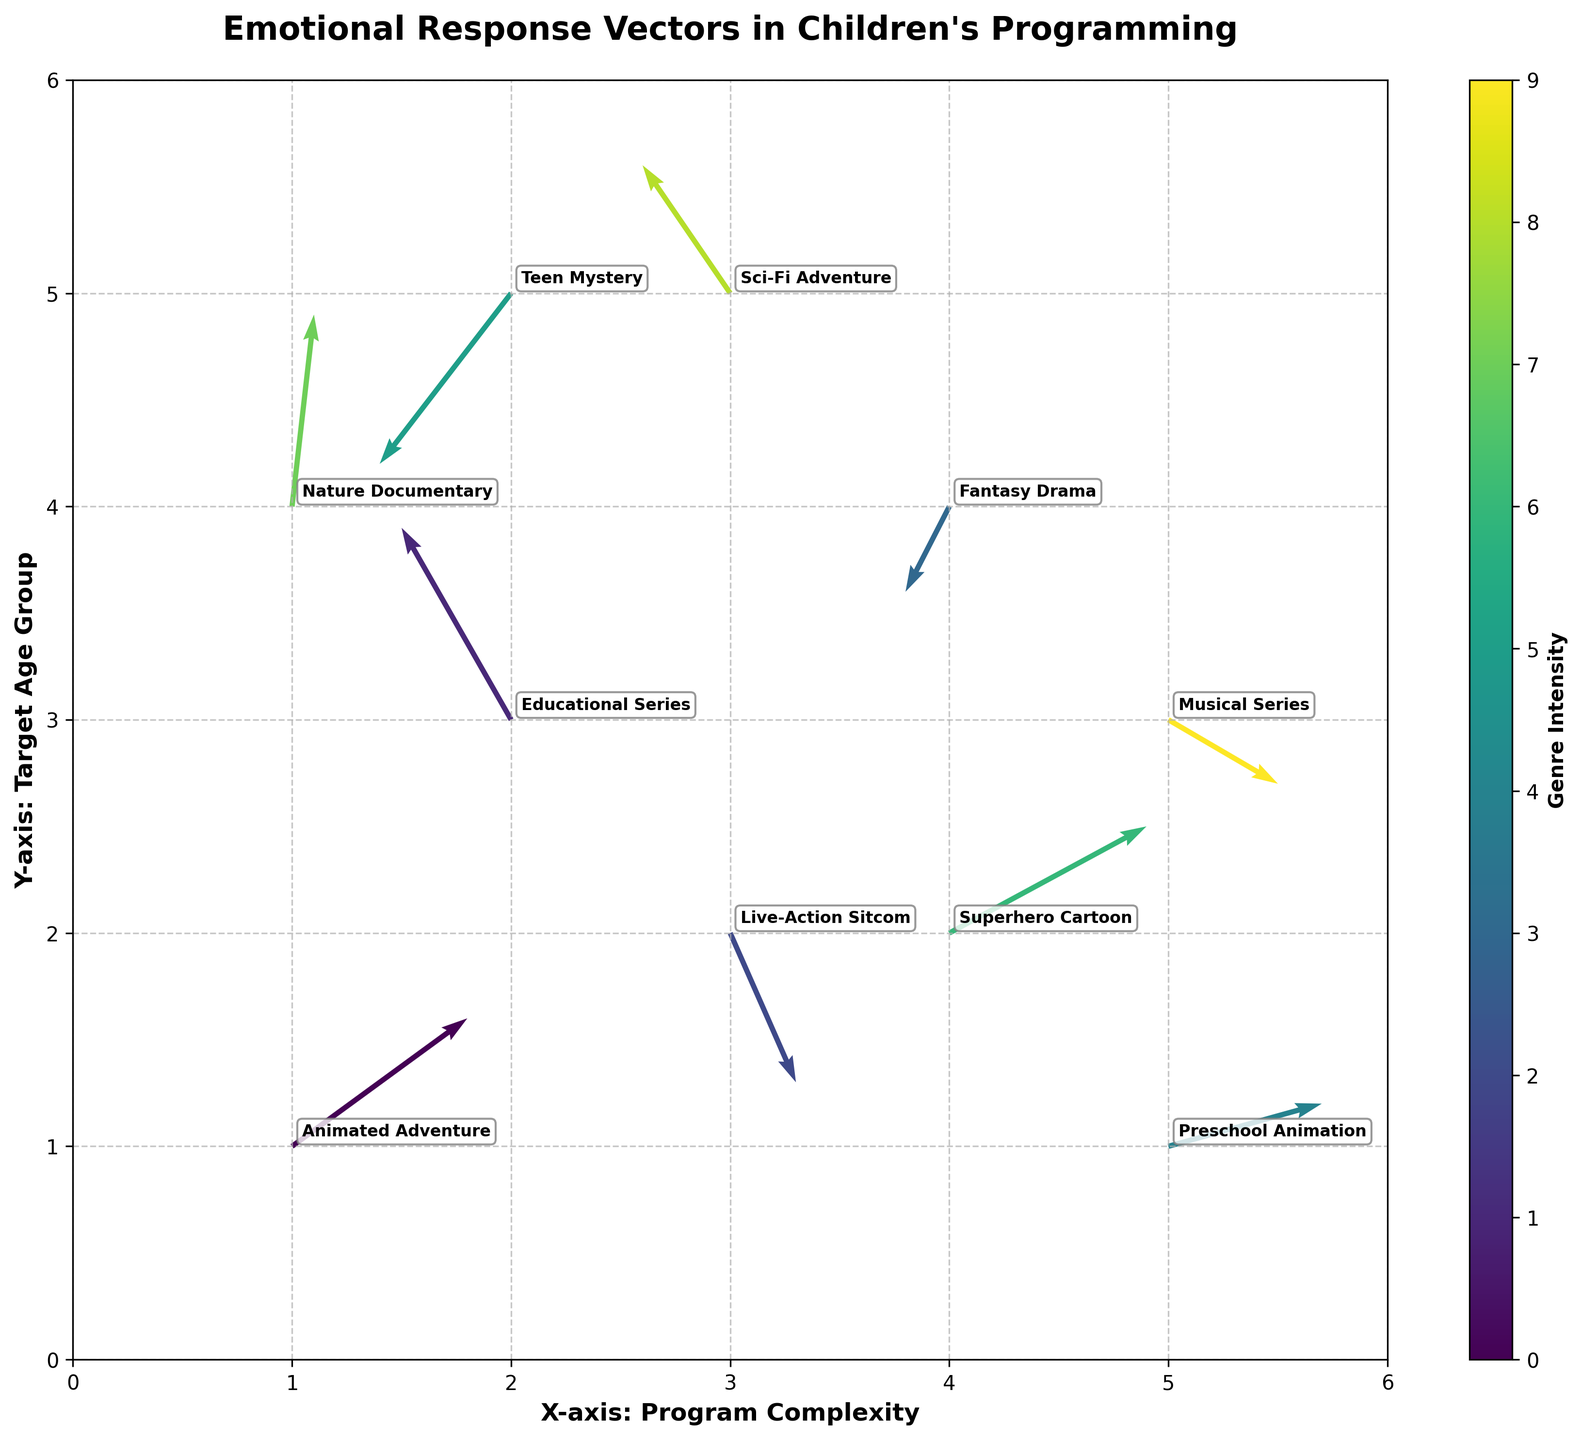What's the title of the plot? The title of the plot is prominently displayed at the top. It is "Emotional Response Vectors in Children's Programming".
Answer: Emotional Response Vectors in Children's Programming What are the labels of the x and y axes? The labels of the x and y axes can be seen along the sides of the plot. The x-axis is labeled "X-axis: Program Complexity" and the y-axis is labeled "Y-axis: Target Age Group".
Answer: X-axis: Program Complexity, Y-axis: Target Age Group How many data points (arrows) are there in the plot? By counting the arrows present in the figure, we can see there are a total of 10 data points.
Answer: 10 Which genre has a vector pointing mostly vertically upwards? We need to find the arrow with a larger vertical component (v) than the horizontal component (u). The "Nature Documentary" has a vertical component (v=0.9) which is significantly larger than its horizontal component (u=0.1).
Answer: Nature Documentary What is the shortest arrow in the plot and which genre does it represent? To find the shortest arrow, we need to look at the lengths of the arrows. The arrow for "Fantasy Drama" has the smallest components (u=-0.2, v=-0.4). The vector length can be calculated as √(u² + v²).
Answer: Fantasy Drama Which genre has a vector with the largest horizontal component? We need to look for the vector with the highest absolute value of the horizontal component (u). The "Superhero Cartoon" has a horizontal component of u=0.9.
Answer: Superhero Cartoon Identify the genre whose vector points to the top left. A vector pointing to the top left will have a negative horizontal component (u) and a positive vertical component (v). The "Educational Series" fits this criterion with u=-0.5 and v=0.9.
Answer: Educational Series Compare the vectors of "Animated Adventure" and "Superhero Cartoon". Which one has a higher vertical component? We need to compare the vertical components (v) of both genres. The "Superhero Cartoon" has a vertical component of v=0.5, and "Animated Adventure" has v=0.6.
Answer: Animated Adventure Which genre starts at the coordinates (3,2), and what direction does its arrow point? We need to identify the genre located at (3,2). Looking at the data, the "Live-Action Sitcom" starts at (3,2) and points in the direction of (0.3,-0.7).
Answer: Live-Action Sitcom, points downwards Which vector has almost equal components in both x and y directions, and what genre does it represent? We need to find the vector where the horizontal and vertical components are nearly the same in magnitude. The "Animated Adventure" has components u=0.8 and v=0.6 which are quite similar.
Answer: Animated Adventure 